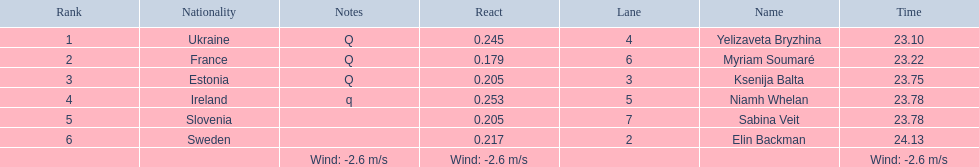Which athlete is from sweden? Elin Backman. What was their time to finish the race? 24.13. 